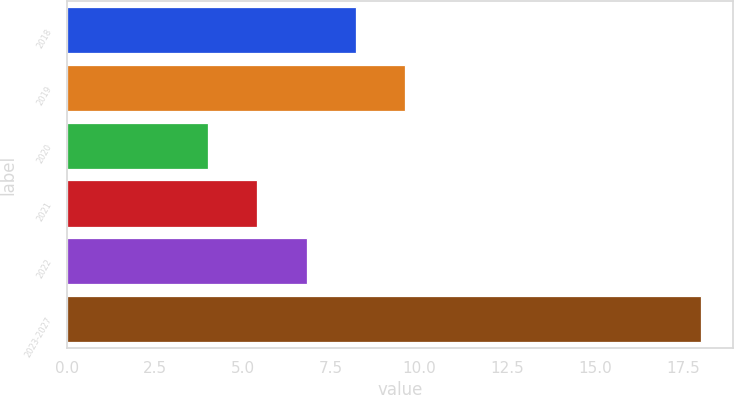<chart> <loc_0><loc_0><loc_500><loc_500><bar_chart><fcel>2018<fcel>2019<fcel>2020<fcel>2021<fcel>2022<fcel>2023-2027<nl><fcel>8.2<fcel>9.6<fcel>4<fcel>5.4<fcel>6.8<fcel>18<nl></chart> 